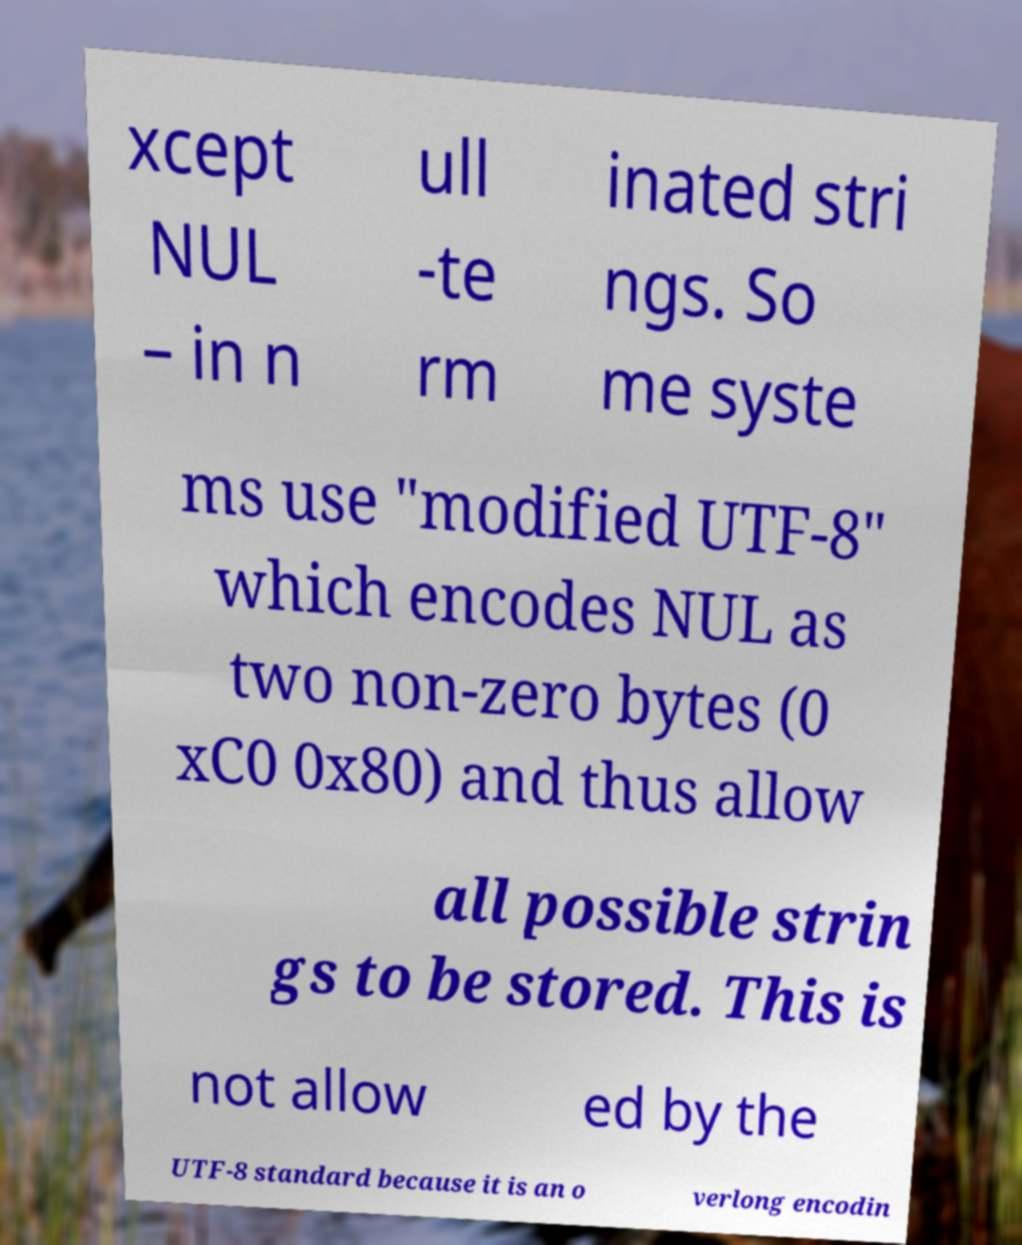There's text embedded in this image that I need extracted. Can you transcribe it verbatim? xcept NUL – in n ull -te rm inated stri ngs. So me syste ms use "modified UTF-8" which encodes NUL as two non-zero bytes (0 xC0 0x80) and thus allow all possible strin gs to be stored. This is not allow ed by the UTF-8 standard because it is an o verlong encodin 